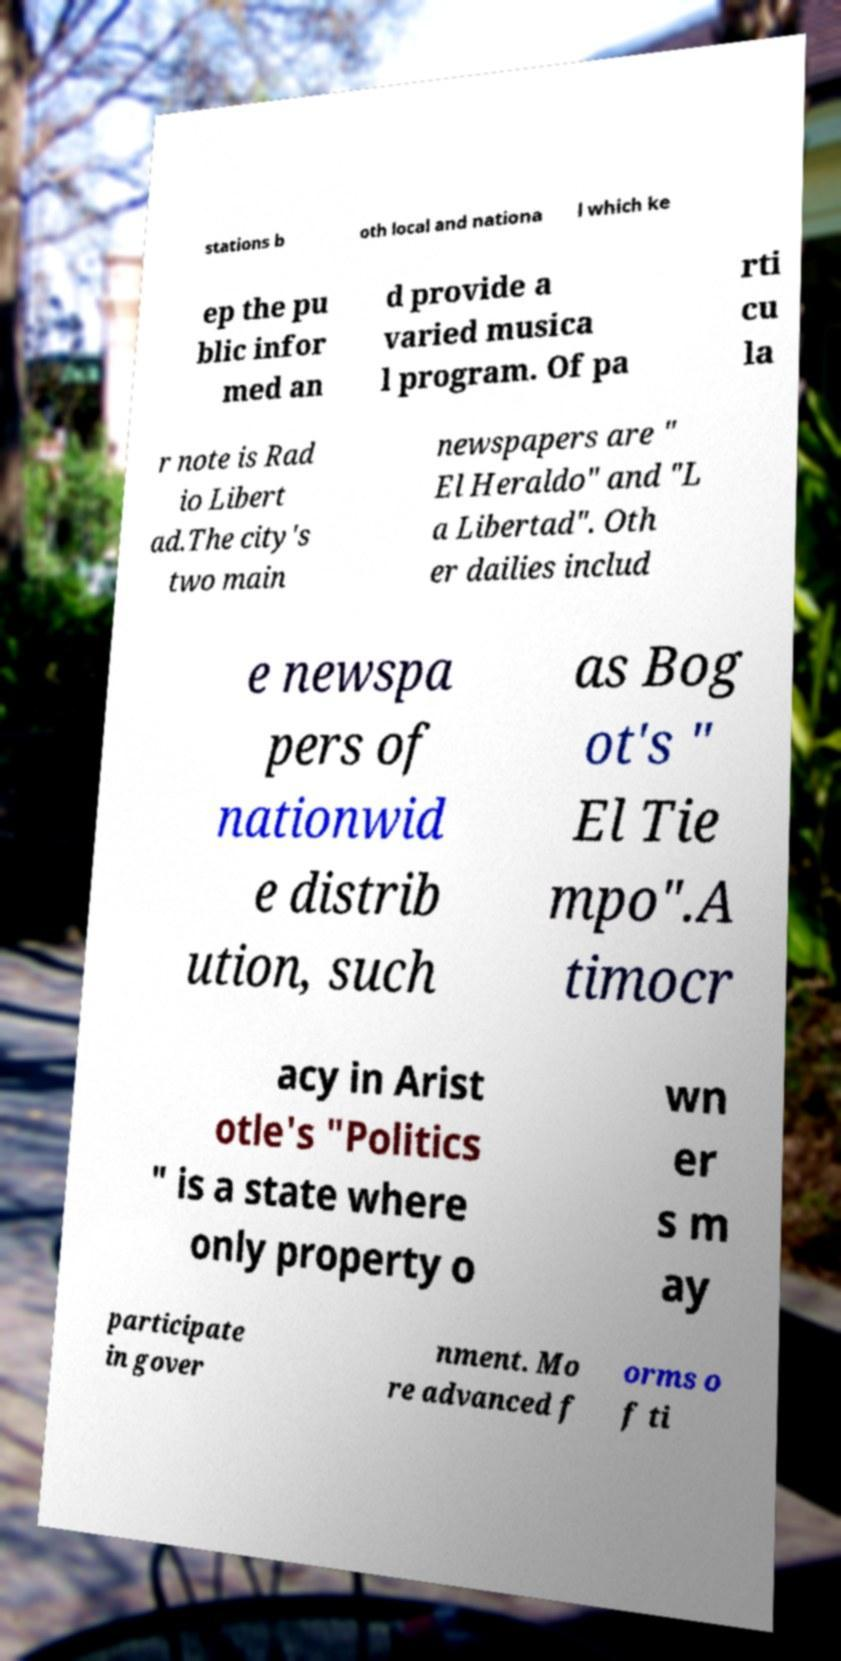Please read and relay the text visible in this image. What does it say? stations b oth local and nationa l which ke ep the pu blic infor med an d provide a varied musica l program. Of pa rti cu la r note is Rad io Libert ad.The city's two main newspapers are " El Heraldo" and "L a Libertad". Oth er dailies includ e newspa pers of nationwid e distrib ution, such as Bog ot's " El Tie mpo".A timocr acy in Arist otle's "Politics " is a state where only property o wn er s m ay participate in gover nment. Mo re advanced f orms o f ti 